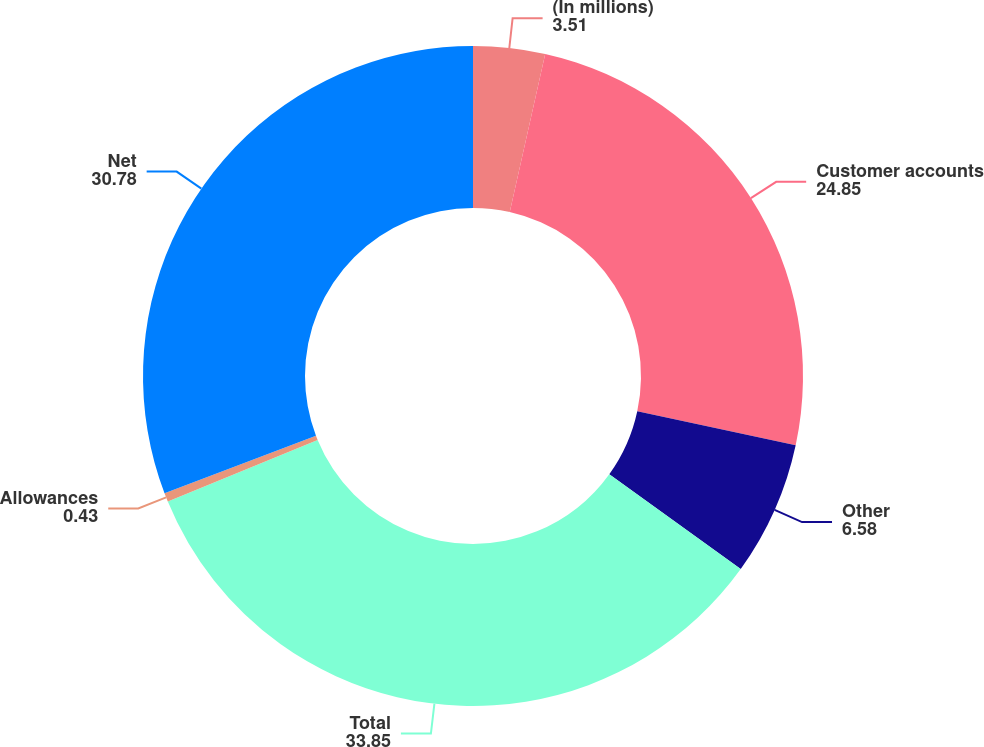Convert chart. <chart><loc_0><loc_0><loc_500><loc_500><pie_chart><fcel>(In millions)<fcel>Customer accounts<fcel>Other<fcel>Total<fcel>Allowances<fcel>Net<nl><fcel>3.51%<fcel>24.85%<fcel>6.58%<fcel>33.85%<fcel>0.43%<fcel>30.78%<nl></chart> 